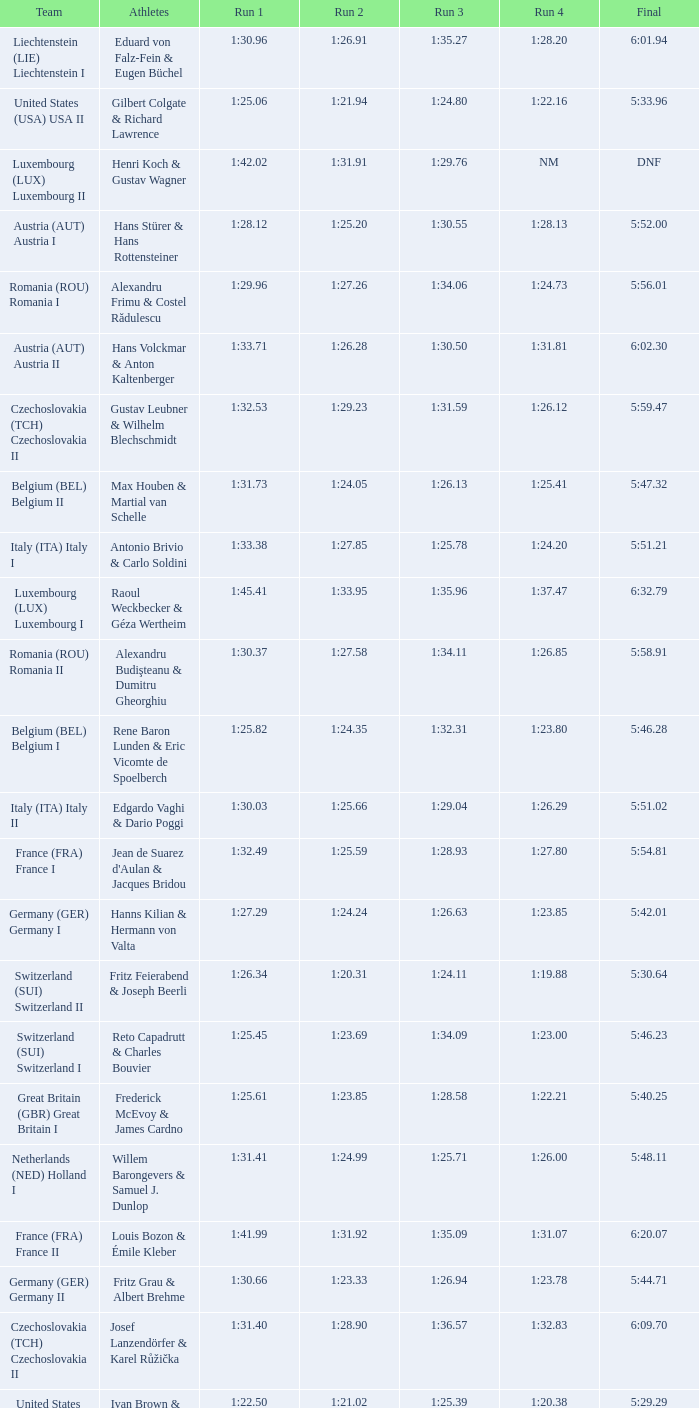Which Run 4 has Athletes of alexandru frimu & costel rădulescu? 1:24.73. Can you give me this table as a dict? {'header': ['Team', 'Athletes', 'Run 1', 'Run 2', 'Run 3', 'Run 4', 'Final'], 'rows': [['Liechtenstein (LIE) Liechtenstein I', 'Eduard von Falz-Fein & Eugen Büchel', '1:30.96', '1:26.91', '1:35.27', '1:28.20', '6:01.94'], ['United States (USA) USA II', 'Gilbert Colgate & Richard Lawrence', '1:25.06', '1:21.94', '1:24.80', '1:22.16', '5:33.96'], ['Luxembourg (LUX) Luxembourg II', 'Henri Koch & Gustav Wagner', '1:42.02', '1:31.91', '1:29.76', 'NM', 'DNF'], ['Austria (AUT) Austria I', 'Hans Stürer & Hans Rottensteiner', '1:28.12', '1:25.20', '1:30.55', '1:28.13', '5:52.00'], ['Romania (ROU) Romania I', 'Alexandru Frimu & Costel Rădulescu', '1:29.96', '1:27.26', '1:34.06', '1:24.73', '5:56.01'], ['Austria (AUT) Austria II', 'Hans Volckmar & Anton Kaltenberger', '1:33.71', '1:26.28', '1:30.50', '1:31.81', '6:02.30'], ['Czechoslovakia (TCH) Czechoslovakia II', 'Gustav Leubner & Wilhelm Blechschmidt', '1:32.53', '1:29.23', '1:31.59', '1:26.12', '5:59.47'], ['Belgium (BEL) Belgium II', 'Max Houben & Martial van Schelle', '1:31.73', '1:24.05', '1:26.13', '1:25.41', '5:47.32'], ['Italy (ITA) Italy I', 'Antonio Brivio & Carlo Soldini', '1:33.38', '1:27.85', '1:25.78', '1:24.20', '5:51.21'], ['Luxembourg (LUX) Luxembourg I', 'Raoul Weckbecker & Géza Wertheim', '1:45.41', '1:33.95', '1:35.96', '1:37.47', '6:32.79'], ['Romania (ROU) Romania II', 'Alexandru Budişteanu & Dumitru Gheorghiu', '1:30.37', '1:27.58', '1:34.11', '1:26.85', '5:58.91'], ['Belgium (BEL) Belgium I', 'Rene Baron Lunden & Eric Vicomte de Spoelberch', '1:25.82', '1:24.35', '1:32.31', '1:23.80', '5:46.28'], ['Italy (ITA) Italy II', 'Edgardo Vaghi & Dario Poggi', '1:30.03', '1:25.66', '1:29.04', '1:26.29', '5:51.02'], ['France (FRA) France I', "Jean de Suarez d'Aulan & Jacques Bridou", '1:32.49', '1:25.59', '1:28.93', '1:27.80', '5:54.81'], ['Germany (GER) Germany I', 'Hanns Kilian & Hermann von Valta', '1:27.29', '1:24.24', '1:26.63', '1:23.85', '5:42.01'], ['Switzerland (SUI) Switzerland II', 'Fritz Feierabend & Joseph Beerli', '1:26.34', '1:20.31', '1:24.11', '1:19.88', '5:30.64'], ['Switzerland (SUI) Switzerland I', 'Reto Capadrutt & Charles Bouvier', '1:25.45', '1:23.69', '1:34.09', '1:23.00', '5:46.23'], ['Great Britain (GBR) Great Britain I', 'Frederick McEvoy & James Cardno', '1:25.61', '1:23.85', '1:28.58', '1:22.21', '5:40.25'], ['Netherlands (NED) Holland I', 'Willem Barongevers & Samuel J. Dunlop', '1:31.41', '1:24.99', '1:25.71', '1:26.00', '5:48.11'], ['France (FRA) France II', 'Louis Bozon & Émile Kleber', '1:41.99', '1:31.92', '1:35.09', '1:31.07', '6:20.07'], ['Germany (GER) Germany II', 'Fritz Grau & Albert Brehme', '1:30.66', '1:23.33', '1:26.94', '1:23.78', '5:44.71'], ['Czechoslovakia (TCH) Czechoslovakia II', 'Josef Lanzendörfer & Karel Růžička', '1:31.40', '1:28.90', '1:36.57', '1:32.83', '6:09.70'], ['United States (USA) USA I', 'Ivan Brown & Alan Washbond', '1:22.50', '1:21.02', '1:25.39', '1:20.38', '5:29.29']]} 